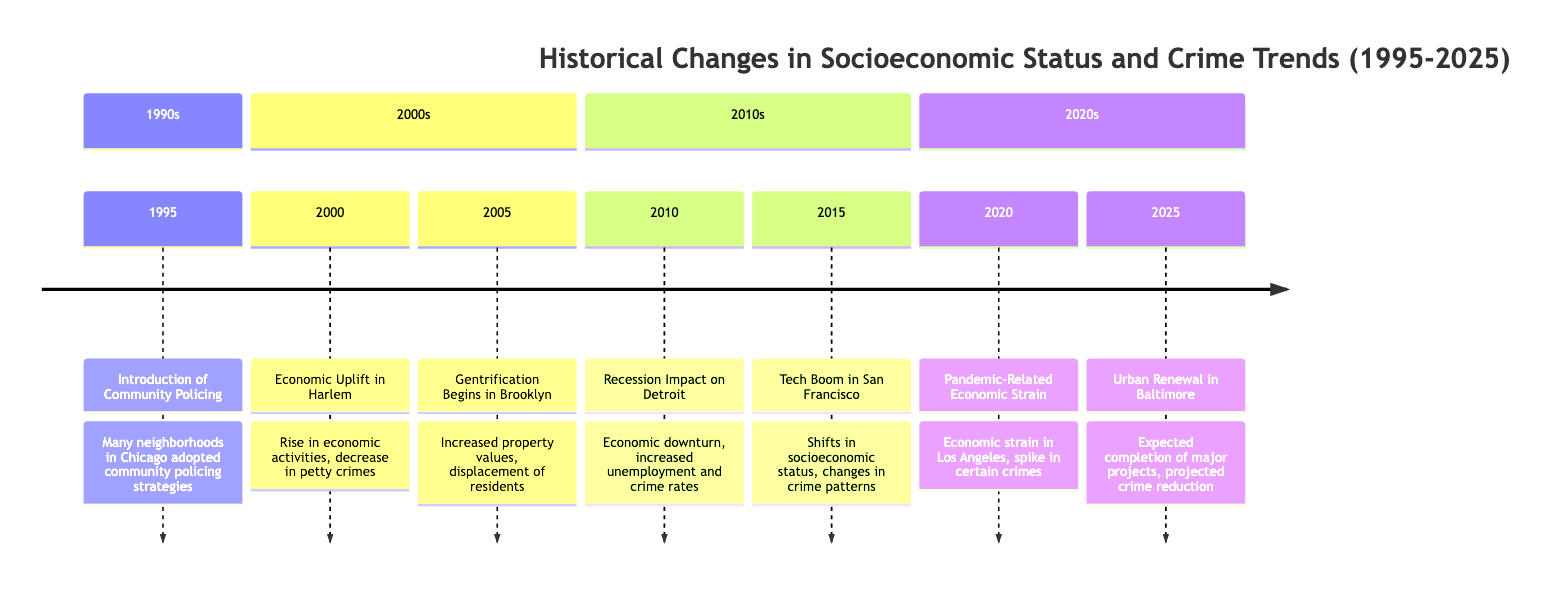What year did the Tech Boom in San Francisco occur? The timeline indicates the event "Tech Boom in San Francisco" is listed under the year 2015. This is a straightforward retrieval of information from the diagram.
Answer: 2015 How did the Economic Uplift in Harlem affect crime? The event for "Economic Uplift in Harlem" states there was a "decrease in petty crimes," directly linking the economic improvement to positive crime trends.
Answer: Decrease in petty crimes What event began in 2005 in Brooklyn? The timeline marks "Gentrification Begins in Brooklyn" as the significant event that started in 2005, indicating a shift in socio-economic conditions.
Answer: Gentrification Begins in Brooklyn Which city's neighborhoods were impacted by the recession in 2010? The description associated with "Recession Impact on Detroit" specifies that the economic downturn affected neighborhoods in Detroit, which indicates the geographical area affected.
Answer: Detroit What is projected to happen in Baltimore by 2025? The timeline outlines an event for 2025 that states "Urban Renewal in Baltimore" is expected to be completed, which is a direct projection from the diagram.
Answer: Crime reduction Which event in 2020 caused a spike in certain crimes? According to the timeline, the event "Pandemic-Related Economic Strain" in 2020 resulted in a temporary spike in certain types of crimes.
Answer: Pandemic-Related Economic Strain How many events are listed in the 2010s section of the timeline? There are two events listed under the 2010s section: "Recession Impact on Detroit" and "Tech Boom in San Francisco." Thus, a count of these events gives the answer.
Answer: 2 In which neighborhood did community policing begin? The timeline specifies that community policing was introduced in various neighborhoods, specifically noting Chicago, linking the crime reduction strategy to its geographic location.
Answer: Chicago What was a notable result of the Tech Boom in San Francisco? The timeline states that the Tech Boom in San Francisco led to a "decrease in some crimes" and an "uptick in property crimes," iterating the mixed effects of economic uplift on crime.
Answer: Decrease in some crimes and uptick in property crimes 